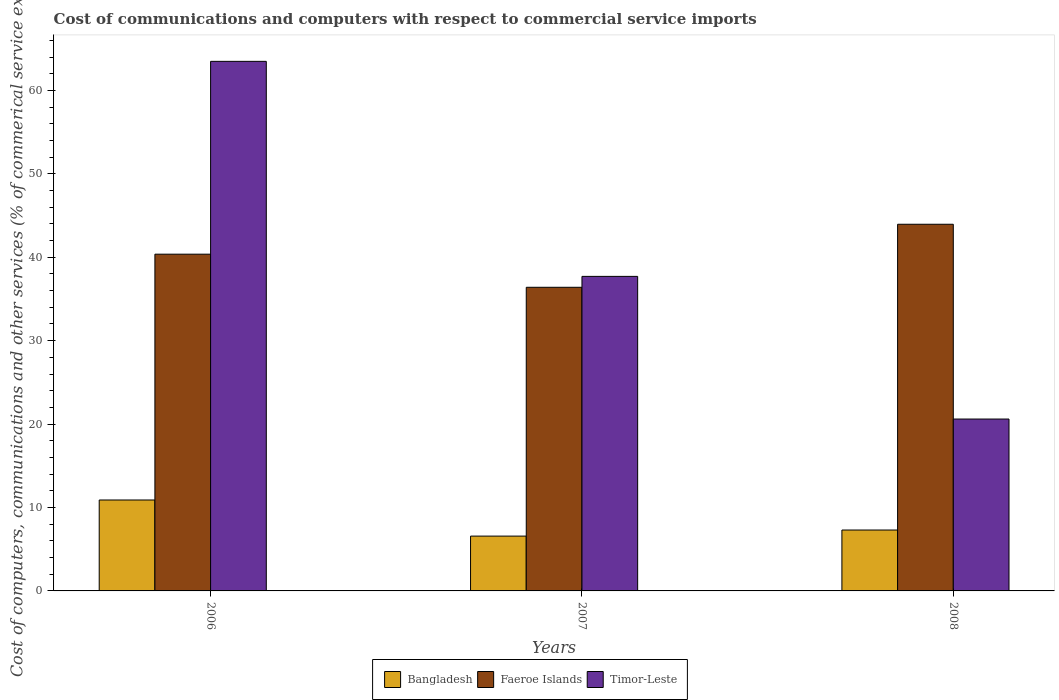How many groups of bars are there?
Your answer should be very brief. 3. How many bars are there on the 1st tick from the left?
Give a very brief answer. 3. What is the cost of communications and computers in Faeroe Islands in 2007?
Give a very brief answer. 36.4. Across all years, what is the maximum cost of communications and computers in Bangladesh?
Offer a very short reply. 10.9. Across all years, what is the minimum cost of communications and computers in Faeroe Islands?
Your response must be concise. 36.4. In which year was the cost of communications and computers in Timor-Leste maximum?
Ensure brevity in your answer.  2006. In which year was the cost of communications and computers in Faeroe Islands minimum?
Provide a short and direct response. 2007. What is the total cost of communications and computers in Bangladesh in the graph?
Provide a succinct answer. 24.77. What is the difference between the cost of communications and computers in Timor-Leste in 2006 and that in 2008?
Your response must be concise. 42.88. What is the difference between the cost of communications and computers in Faeroe Islands in 2007 and the cost of communications and computers in Bangladesh in 2006?
Offer a terse response. 25.5. What is the average cost of communications and computers in Timor-Leste per year?
Give a very brief answer. 40.6. In the year 2008, what is the difference between the cost of communications and computers in Bangladesh and cost of communications and computers in Faeroe Islands?
Your answer should be very brief. -36.66. In how many years, is the cost of communications and computers in Faeroe Islands greater than 42 %?
Provide a succinct answer. 1. What is the ratio of the cost of communications and computers in Bangladesh in 2006 to that in 2007?
Ensure brevity in your answer.  1.66. Is the difference between the cost of communications and computers in Bangladesh in 2006 and 2007 greater than the difference between the cost of communications and computers in Faeroe Islands in 2006 and 2007?
Offer a terse response. Yes. What is the difference between the highest and the second highest cost of communications and computers in Faeroe Islands?
Your answer should be compact. 3.59. What is the difference between the highest and the lowest cost of communications and computers in Bangladesh?
Your answer should be very brief. 4.33. What does the 3rd bar from the left in 2008 represents?
Make the answer very short. Timor-Leste. How many bars are there?
Make the answer very short. 9. Are all the bars in the graph horizontal?
Offer a terse response. No. What is the difference between two consecutive major ticks on the Y-axis?
Your answer should be very brief. 10. Does the graph contain any zero values?
Provide a short and direct response. No. Where does the legend appear in the graph?
Your response must be concise. Bottom center. How many legend labels are there?
Provide a short and direct response. 3. What is the title of the graph?
Offer a terse response. Cost of communications and computers with respect to commercial service imports. Does "Isle of Man" appear as one of the legend labels in the graph?
Offer a terse response. No. What is the label or title of the X-axis?
Provide a succinct answer. Years. What is the label or title of the Y-axis?
Keep it short and to the point. Cost of computers, communications and other services (% of commerical service exports). What is the Cost of computers, communications and other services (% of commerical service exports) of Bangladesh in 2006?
Ensure brevity in your answer.  10.9. What is the Cost of computers, communications and other services (% of commerical service exports) of Faeroe Islands in 2006?
Ensure brevity in your answer.  40.37. What is the Cost of computers, communications and other services (% of commerical service exports) in Timor-Leste in 2006?
Give a very brief answer. 63.49. What is the Cost of computers, communications and other services (% of commerical service exports) of Bangladesh in 2007?
Your answer should be compact. 6.57. What is the Cost of computers, communications and other services (% of commerical service exports) in Faeroe Islands in 2007?
Keep it short and to the point. 36.4. What is the Cost of computers, communications and other services (% of commerical service exports) in Timor-Leste in 2007?
Keep it short and to the point. 37.71. What is the Cost of computers, communications and other services (% of commerical service exports) of Bangladesh in 2008?
Provide a short and direct response. 7.3. What is the Cost of computers, communications and other services (% of commerical service exports) in Faeroe Islands in 2008?
Offer a very short reply. 43.96. What is the Cost of computers, communications and other services (% of commerical service exports) of Timor-Leste in 2008?
Offer a terse response. 20.61. Across all years, what is the maximum Cost of computers, communications and other services (% of commerical service exports) in Bangladesh?
Give a very brief answer. 10.9. Across all years, what is the maximum Cost of computers, communications and other services (% of commerical service exports) in Faeroe Islands?
Provide a short and direct response. 43.96. Across all years, what is the maximum Cost of computers, communications and other services (% of commerical service exports) in Timor-Leste?
Your answer should be compact. 63.49. Across all years, what is the minimum Cost of computers, communications and other services (% of commerical service exports) of Bangladesh?
Offer a very short reply. 6.57. Across all years, what is the minimum Cost of computers, communications and other services (% of commerical service exports) in Faeroe Islands?
Your response must be concise. 36.4. Across all years, what is the minimum Cost of computers, communications and other services (% of commerical service exports) in Timor-Leste?
Provide a short and direct response. 20.61. What is the total Cost of computers, communications and other services (% of commerical service exports) of Bangladesh in the graph?
Keep it short and to the point. 24.77. What is the total Cost of computers, communications and other services (% of commerical service exports) of Faeroe Islands in the graph?
Your answer should be compact. 120.73. What is the total Cost of computers, communications and other services (% of commerical service exports) of Timor-Leste in the graph?
Offer a very short reply. 121.8. What is the difference between the Cost of computers, communications and other services (% of commerical service exports) of Bangladesh in 2006 and that in 2007?
Your response must be concise. 4.33. What is the difference between the Cost of computers, communications and other services (% of commerical service exports) in Faeroe Islands in 2006 and that in 2007?
Offer a terse response. 3.97. What is the difference between the Cost of computers, communications and other services (% of commerical service exports) in Timor-Leste in 2006 and that in 2007?
Make the answer very short. 25.78. What is the difference between the Cost of computers, communications and other services (% of commerical service exports) in Bangladesh in 2006 and that in 2008?
Provide a short and direct response. 3.6. What is the difference between the Cost of computers, communications and other services (% of commerical service exports) of Faeroe Islands in 2006 and that in 2008?
Your response must be concise. -3.59. What is the difference between the Cost of computers, communications and other services (% of commerical service exports) of Timor-Leste in 2006 and that in 2008?
Ensure brevity in your answer.  42.88. What is the difference between the Cost of computers, communications and other services (% of commerical service exports) of Bangladesh in 2007 and that in 2008?
Provide a succinct answer. -0.73. What is the difference between the Cost of computers, communications and other services (% of commerical service exports) of Faeroe Islands in 2007 and that in 2008?
Offer a terse response. -7.56. What is the difference between the Cost of computers, communications and other services (% of commerical service exports) in Timor-Leste in 2007 and that in 2008?
Provide a succinct answer. 17.1. What is the difference between the Cost of computers, communications and other services (% of commerical service exports) of Bangladesh in 2006 and the Cost of computers, communications and other services (% of commerical service exports) of Faeroe Islands in 2007?
Your answer should be compact. -25.5. What is the difference between the Cost of computers, communications and other services (% of commerical service exports) in Bangladesh in 2006 and the Cost of computers, communications and other services (% of commerical service exports) in Timor-Leste in 2007?
Provide a succinct answer. -26.81. What is the difference between the Cost of computers, communications and other services (% of commerical service exports) in Faeroe Islands in 2006 and the Cost of computers, communications and other services (% of commerical service exports) in Timor-Leste in 2007?
Ensure brevity in your answer.  2.66. What is the difference between the Cost of computers, communications and other services (% of commerical service exports) of Bangladesh in 2006 and the Cost of computers, communications and other services (% of commerical service exports) of Faeroe Islands in 2008?
Offer a very short reply. -33.06. What is the difference between the Cost of computers, communications and other services (% of commerical service exports) in Bangladesh in 2006 and the Cost of computers, communications and other services (% of commerical service exports) in Timor-Leste in 2008?
Offer a terse response. -9.7. What is the difference between the Cost of computers, communications and other services (% of commerical service exports) in Faeroe Islands in 2006 and the Cost of computers, communications and other services (% of commerical service exports) in Timor-Leste in 2008?
Keep it short and to the point. 19.76. What is the difference between the Cost of computers, communications and other services (% of commerical service exports) in Bangladesh in 2007 and the Cost of computers, communications and other services (% of commerical service exports) in Faeroe Islands in 2008?
Provide a short and direct response. -37.38. What is the difference between the Cost of computers, communications and other services (% of commerical service exports) of Bangladesh in 2007 and the Cost of computers, communications and other services (% of commerical service exports) of Timor-Leste in 2008?
Your answer should be very brief. -14.03. What is the difference between the Cost of computers, communications and other services (% of commerical service exports) of Faeroe Islands in 2007 and the Cost of computers, communications and other services (% of commerical service exports) of Timor-Leste in 2008?
Your answer should be very brief. 15.79. What is the average Cost of computers, communications and other services (% of commerical service exports) in Bangladesh per year?
Ensure brevity in your answer.  8.26. What is the average Cost of computers, communications and other services (% of commerical service exports) in Faeroe Islands per year?
Make the answer very short. 40.24. What is the average Cost of computers, communications and other services (% of commerical service exports) in Timor-Leste per year?
Provide a succinct answer. 40.6. In the year 2006, what is the difference between the Cost of computers, communications and other services (% of commerical service exports) of Bangladesh and Cost of computers, communications and other services (% of commerical service exports) of Faeroe Islands?
Your answer should be very brief. -29.47. In the year 2006, what is the difference between the Cost of computers, communications and other services (% of commerical service exports) of Bangladesh and Cost of computers, communications and other services (% of commerical service exports) of Timor-Leste?
Ensure brevity in your answer.  -52.59. In the year 2006, what is the difference between the Cost of computers, communications and other services (% of commerical service exports) in Faeroe Islands and Cost of computers, communications and other services (% of commerical service exports) in Timor-Leste?
Offer a very short reply. -23.12. In the year 2007, what is the difference between the Cost of computers, communications and other services (% of commerical service exports) of Bangladesh and Cost of computers, communications and other services (% of commerical service exports) of Faeroe Islands?
Offer a very short reply. -29.83. In the year 2007, what is the difference between the Cost of computers, communications and other services (% of commerical service exports) in Bangladesh and Cost of computers, communications and other services (% of commerical service exports) in Timor-Leste?
Your response must be concise. -31.14. In the year 2007, what is the difference between the Cost of computers, communications and other services (% of commerical service exports) in Faeroe Islands and Cost of computers, communications and other services (% of commerical service exports) in Timor-Leste?
Your response must be concise. -1.31. In the year 2008, what is the difference between the Cost of computers, communications and other services (% of commerical service exports) of Bangladesh and Cost of computers, communications and other services (% of commerical service exports) of Faeroe Islands?
Keep it short and to the point. -36.66. In the year 2008, what is the difference between the Cost of computers, communications and other services (% of commerical service exports) of Bangladesh and Cost of computers, communications and other services (% of commerical service exports) of Timor-Leste?
Provide a short and direct response. -13.31. In the year 2008, what is the difference between the Cost of computers, communications and other services (% of commerical service exports) of Faeroe Islands and Cost of computers, communications and other services (% of commerical service exports) of Timor-Leste?
Your response must be concise. 23.35. What is the ratio of the Cost of computers, communications and other services (% of commerical service exports) of Bangladesh in 2006 to that in 2007?
Offer a terse response. 1.66. What is the ratio of the Cost of computers, communications and other services (% of commerical service exports) in Faeroe Islands in 2006 to that in 2007?
Keep it short and to the point. 1.11. What is the ratio of the Cost of computers, communications and other services (% of commerical service exports) of Timor-Leste in 2006 to that in 2007?
Your answer should be compact. 1.68. What is the ratio of the Cost of computers, communications and other services (% of commerical service exports) in Bangladesh in 2006 to that in 2008?
Your response must be concise. 1.49. What is the ratio of the Cost of computers, communications and other services (% of commerical service exports) in Faeroe Islands in 2006 to that in 2008?
Provide a succinct answer. 0.92. What is the ratio of the Cost of computers, communications and other services (% of commerical service exports) in Timor-Leste in 2006 to that in 2008?
Your answer should be compact. 3.08. What is the ratio of the Cost of computers, communications and other services (% of commerical service exports) of Bangladesh in 2007 to that in 2008?
Your answer should be compact. 0.9. What is the ratio of the Cost of computers, communications and other services (% of commerical service exports) of Faeroe Islands in 2007 to that in 2008?
Your response must be concise. 0.83. What is the ratio of the Cost of computers, communications and other services (% of commerical service exports) in Timor-Leste in 2007 to that in 2008?
Give a very brief answer. 1.83. What is the difference between the highest and the second highest Cost of computers, communications and other services (% of commerical service exports) of Bangladesh?
Your answer should be compact. 3.6. What is the difference between the highest and the second highest Cost of computers, communications and other services (% of commerical service exports) in Faeroe Islands?
Your response must be concise. 3.59. What is the difference between the highest and the second highest Cost of computers, communications and other services (% of commerical service exports) of Timor-Leste?
Make the answer very short. 25.78. What is the difference between the highest and the lowest Cost of computers, communications and other services (% of commerical service exports) of Bangladesh?
Make the answer very short. 4.33. What is the difference between the highest and the lowest Cost of computers, communications and other services (% of commerical service exports) of Faeroe Islands?
Your answer should be very brief. 7.56. What is the difference between the highest and the lowest Cost of computers, communications and other services (% of commerical service exports) of Timor-Leste?
Make the answer very short. 42.88. 